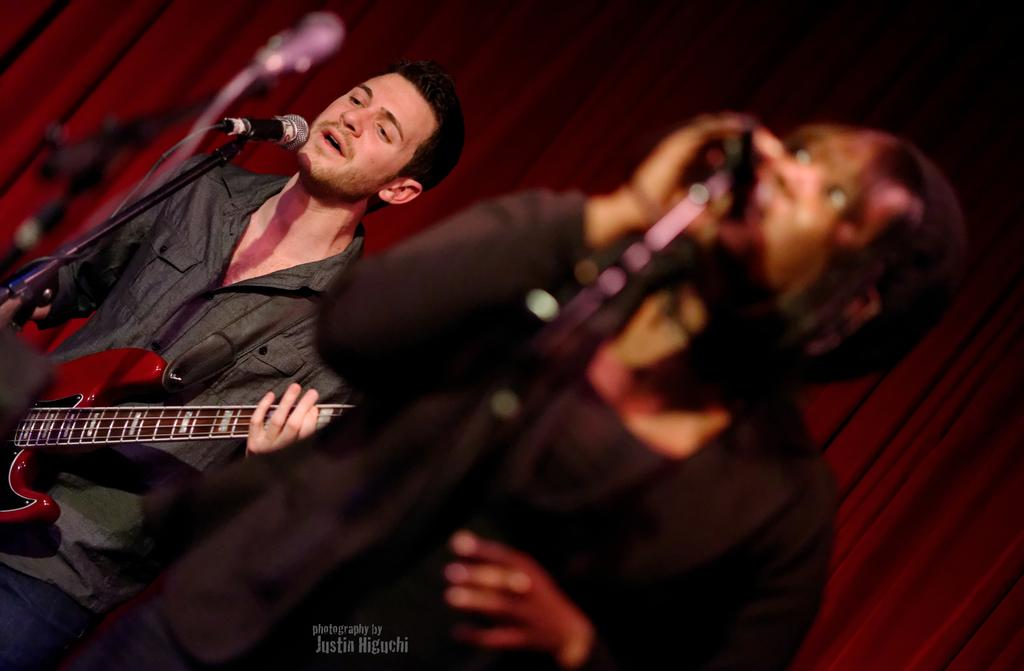How many people are in the image? There are two persons standing in the image. What are the two persons doing? They are singing in the image. How are they amplifying their voices while singing? They are using microphones (mikes) while singing. What instrument is one of the persons playing? One person is playing the guitar. What can be seen in the background of the image? There is a curtain in the background of the image. Can you tell me how many robins are perched on the guitar in the image? There are no robins present in the image; it features two people singing and playing a guitar. What type of nut is being used as a pick for the guitar in the image? There is no nut being used as a pick for the guitar in the image; the person is using their fingers or a traditional guitar pick. 